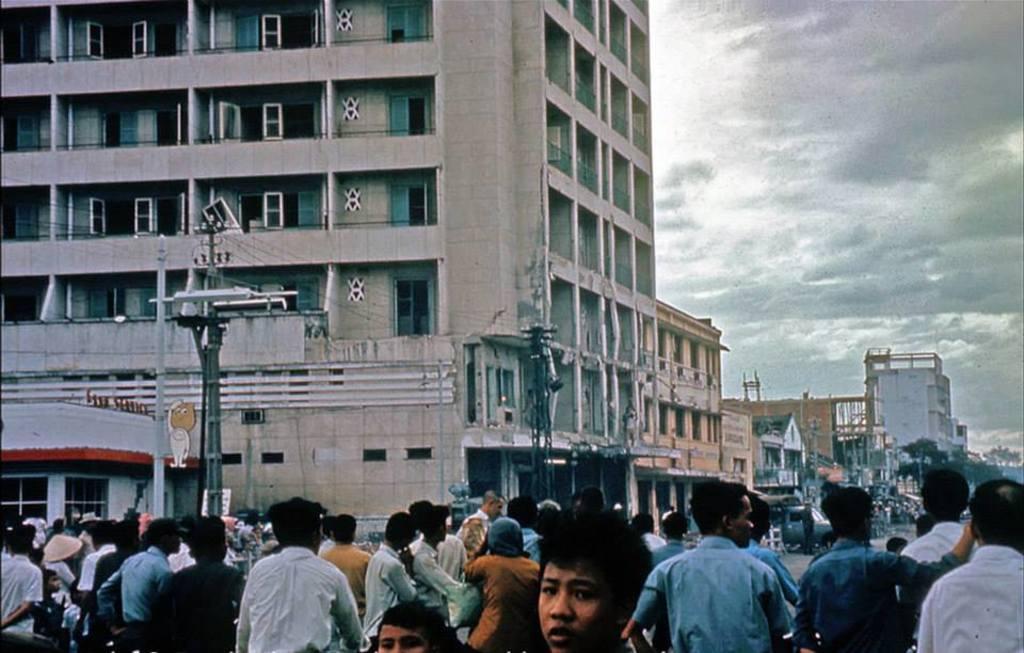Please provide a concise description of this image. In this picture I can see there are a few buildings and it has few doors and windows. There are people standing and there are a few more buildings, there are trees, electric poles with cables and the sky is cloudy. 